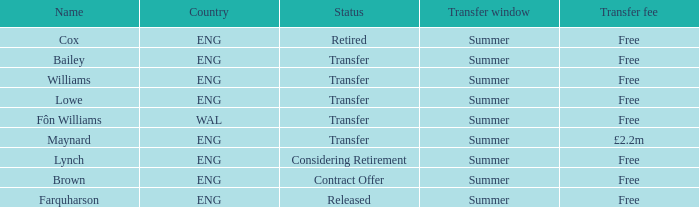Could you parse the entire table? {'header': ['Name', 'Country', 'Status', 'Transfer window', 'Transfer fee'], 'rows': [['Cox', 'ENG', 'Retired', 'Summer', 'Free'], ['Bailey', 'ENG', 'Transfer', 'Summer', 'Free'], ['Williams', 'ENG', 'Transfer', 'Summer', 'Free'], ['Lowe', 'ENG', 'Transfer', 'Summer', 'Free'], ['Fôn Williams', 'WAL', 'Transfer', 'Summer', 'Free'], ['Maynard', 'ENG', 'Transfer', 'Summer', '£2.2m'], ['Lynch', 'ENG', 'Considering Retirement', 'Summer', 'Free'], ['Brown', 'ENG', 'Contract Offer', 'Summer', 'Free'], ['Farquharson', 'ENG', 'Released', 'Summer', 'Free']]} What is the designation of the no-cost transfer fee with a transfer situation and an eng territory? Bailey, Williams, Lowe. 